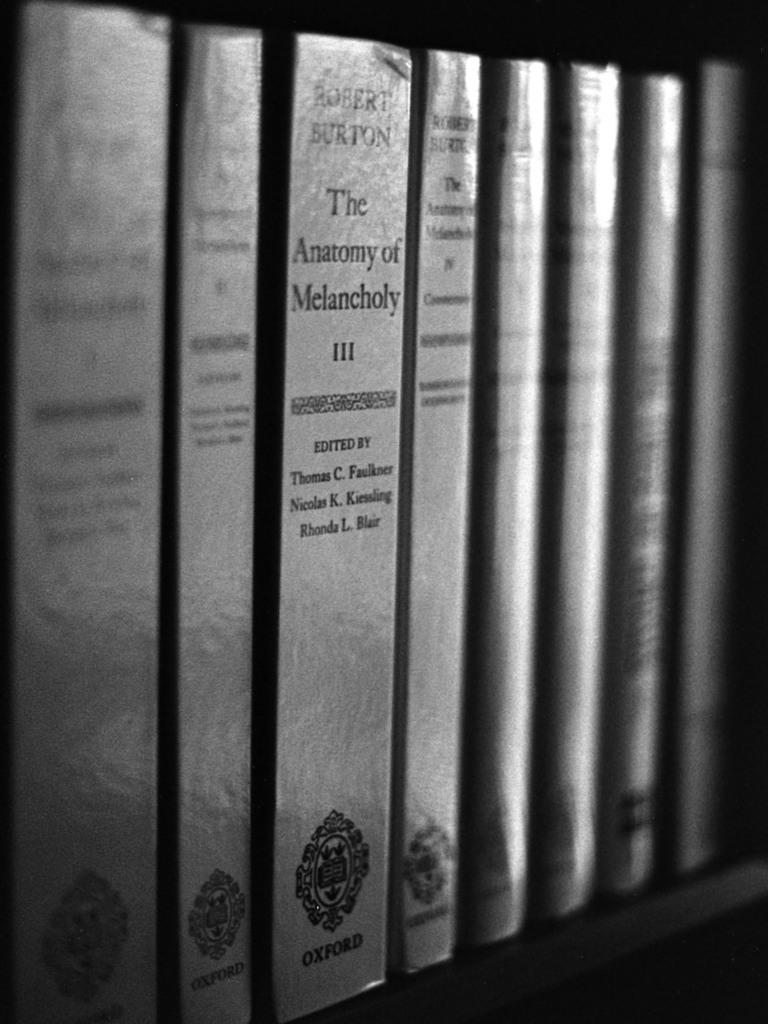<image>
Provide a brief description of the given image. The Anatomy of Melancholy III and other books all have silver covers. 